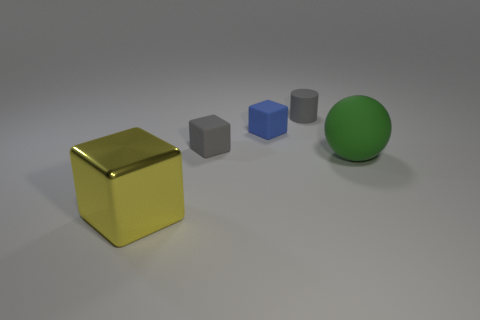How many tiny matte objects are the same shape as the big yellow object?
Your answer should be very brief. 2. Is the color of the small thing that is left of the tiny blue rubber cube the same as the small rubber thing that is behind the tiny blue matte cube?
Your answer should be very brief. Yes. What is the material of the green object that is the same size as the metallic cube?
Your answer should be compact. Rubber. Are there any yellow metallic objects of the same size as the green ball?
Keep it short and to the point. Yes. Are there fewer big yellow shiny blocks that are in front of the large rubber object than gray rubber objects?
Provide a succinct answer. Yes. Is the number of green spheres to the left of the matte cylinder less than the number of large yellow blocks that are to the left of the matte ball?
Give a very brief answer. Yes. What number of cubes are blue objects or gray things?
Offer a very short reply. 2. Is the gray object that is to the left of the gray rubber cylinder made of the same material as the thing that is in front of the green ball?
Offer a very short reply. No. There is a rubber thing that is the same size as the yellow metal object; what is its shape?
Your response must be concise. Sphere. How many other objects are the same color as the big metal cube?
Offer a very short reply. 0. 